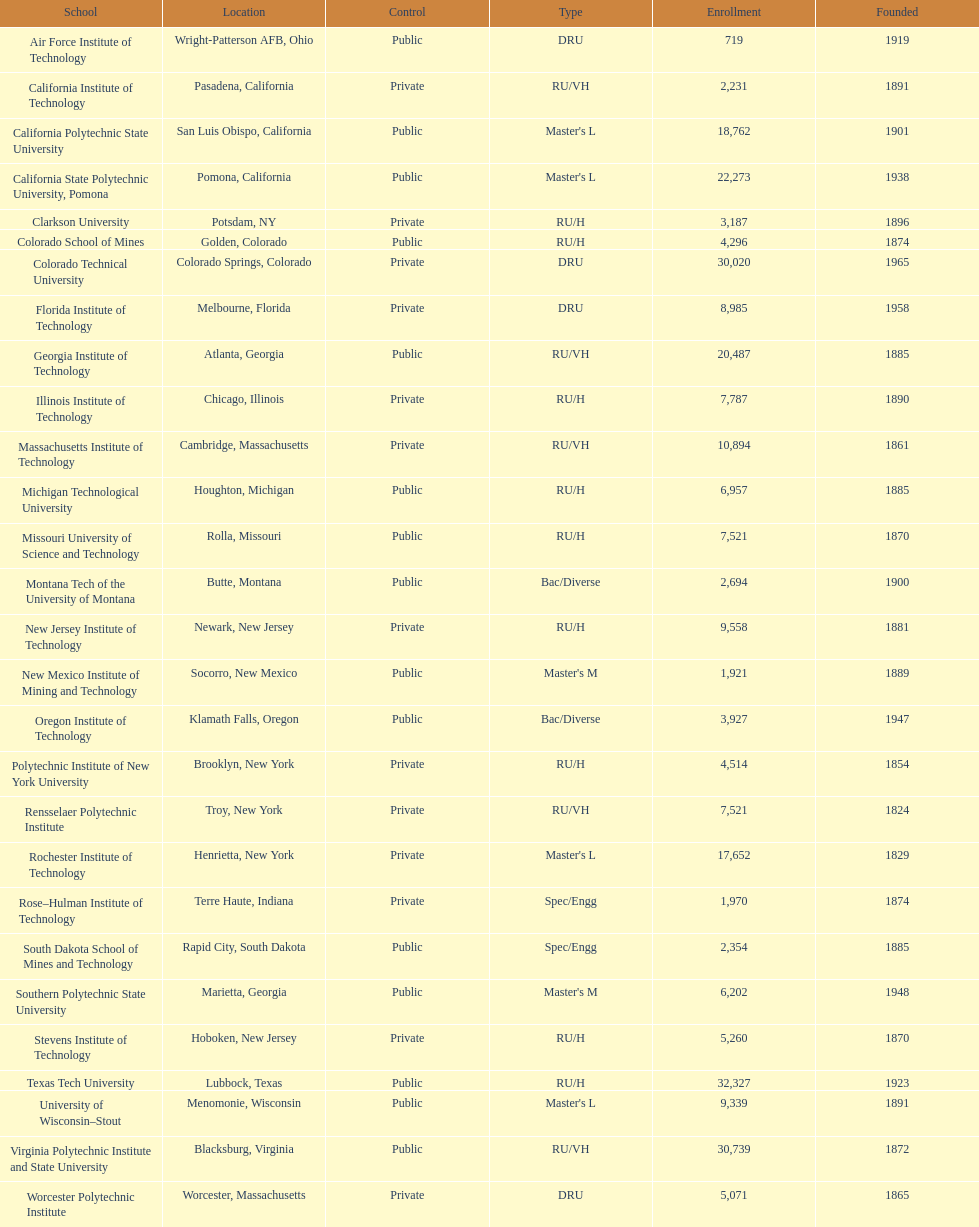What's the number of schools represented in the table? 28. 